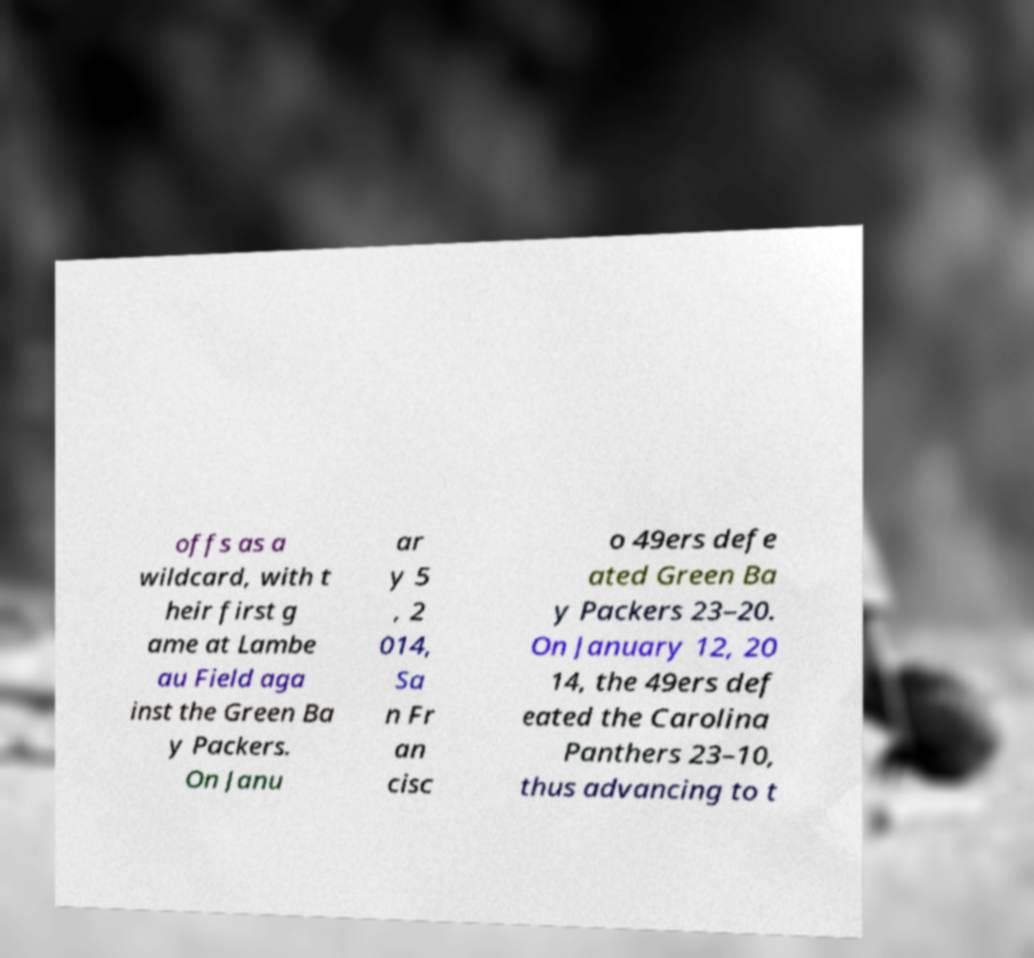I need the written content from this picture converted into text. Can you do that? offs as a wildcard, with t heir first g ame at Lambe au Field aga inst the Green Ba y Packers. On Janu ar y 5 , 2 014, Sa n Fr an cisc o 49ers defe ated Green Ba y Packers 23–20. On January 12, 20 14, the 49ers def eated the Carolina Panthers 23–10, thus advancing to t 